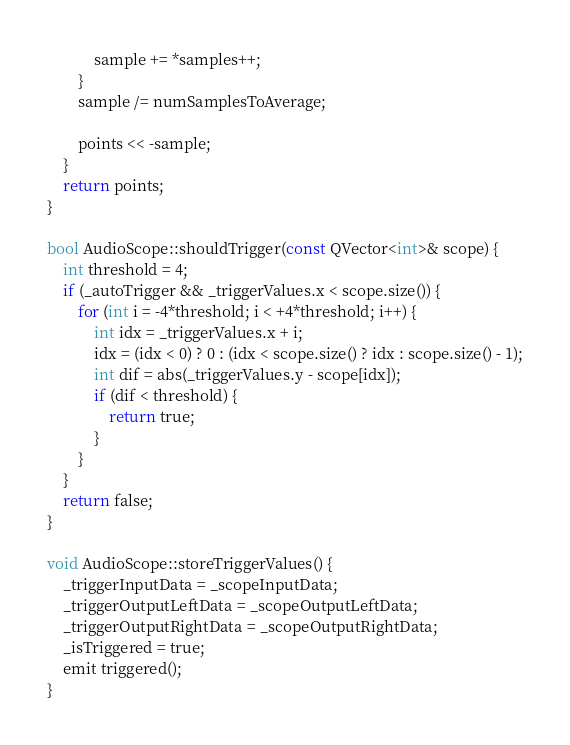Convert code to text. <code><loc_0><loc_0><loc_500><loc_500><_C++_>            sample += *samples++;
        }
        sample /= numSamplesToAverage;

        points << -sample;
    }
    return points;
}

bool AudioScope::shouldTrigger(const QVector<int>& scope) {
    int threshold = 4;
    if (_autoTrigger && _triggerValues.x < scope.size()) {
        for (int i = -4*threshold; i < +4*threshold; i++) {
            int idx = _triggerValues.x + i;
            idx = (idx < 0) ? 0 : (idx < scope.size() ? idx : scope.size() - 1);
            int dif = abs(_triggerValues.y - scope[idx]);
            if (dif < threshold) {
                return true;
            }
        }
    }
    return false;
}

void AudioScope::storeTriggerValues() {
    _triggerInputData = _scopeInputData;
    _triggerOutputLeftData = _scopeOutputLeftData;
    _triggerOutputRightData = _scopeOutputRightData;
    _isTriggered = true;
    emit triggered();
}
</code> 